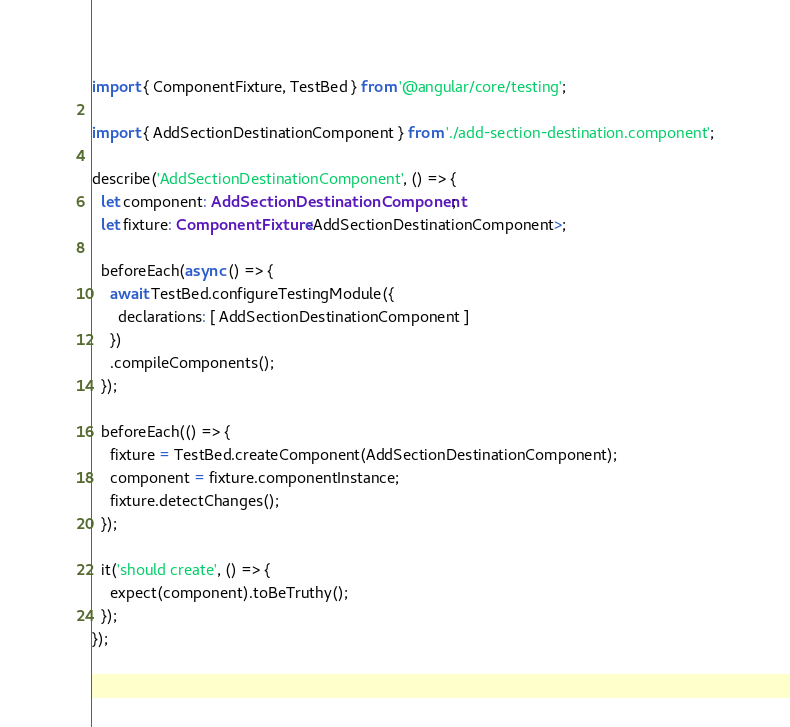Convert code to text. <code><loc_0><loc_0><loc_500><loc_500><_TypeScript_>import { ComponentFixture, TestBed } from '@angular/core/testing';

import { AddSectionDestinationComponent } from './add-section-destination.component';

describe('AddSectionDestinationComponent', () => {
  let component: AddSectionDestinationComponent;
  let fixture: ComponentFixture<AddSectionDestinationComponent>;

  beforeEach(async () => {
    await TestBed.configureTestingModule({
      declarations: [ AddSectionDestinationComponent ]
    })
    .compileComponents();
  });

  beforeEach(() => {
    fixture = TestBed.createComponent(AddSectionDestinationComponent);
    component = fixture.componentInstance;
    fixture.detectChanges();
  });

  it('should create', () => {
    expect(component).toBeTruthy();
  });
});
</code> 